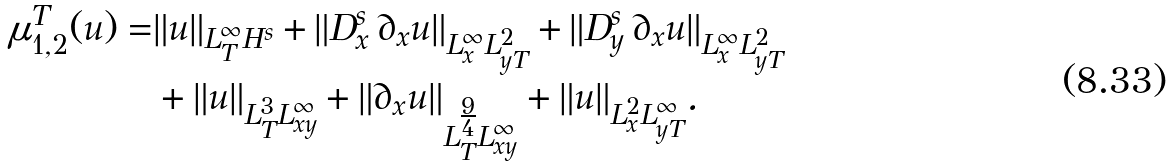<formula> <loc_0><loc_0><loc_500><loc_500>\mu _ { 1 , 2 } ^ { T } ( u ) = & \| u \| _ { L _ { T } ^ { \infty } H ^ { s } } + \| D _ { x } ^ { s } \, \partial _ { x } u \| _ { L _ { x } ^ { \infty } L _ { y T } ^ { 2 } } + \| D _ { y } ^ { s } \, \partial _ { x } u \| _ { L _ { x } ^ { \infty } L _ { y T } ^ { 2 } } \\ & + \| u \| _ { L _ { T } ^ { 3 } L _ { x y } ^ { \infty } } + \| \partial _ { x } u \| _ { L _ { T } ^ { \frac { 9 } { 4 } } L _ { x y } ^ { \infty } } + \| u \| _ { L _ { x } ^ { 2 } L _ { y T } ^ { \infty } } .</formula> 